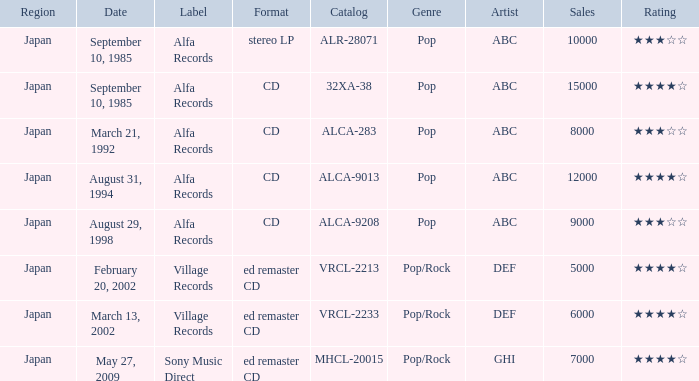Which Label was cataloged as alca-9013? Alfa Records. 